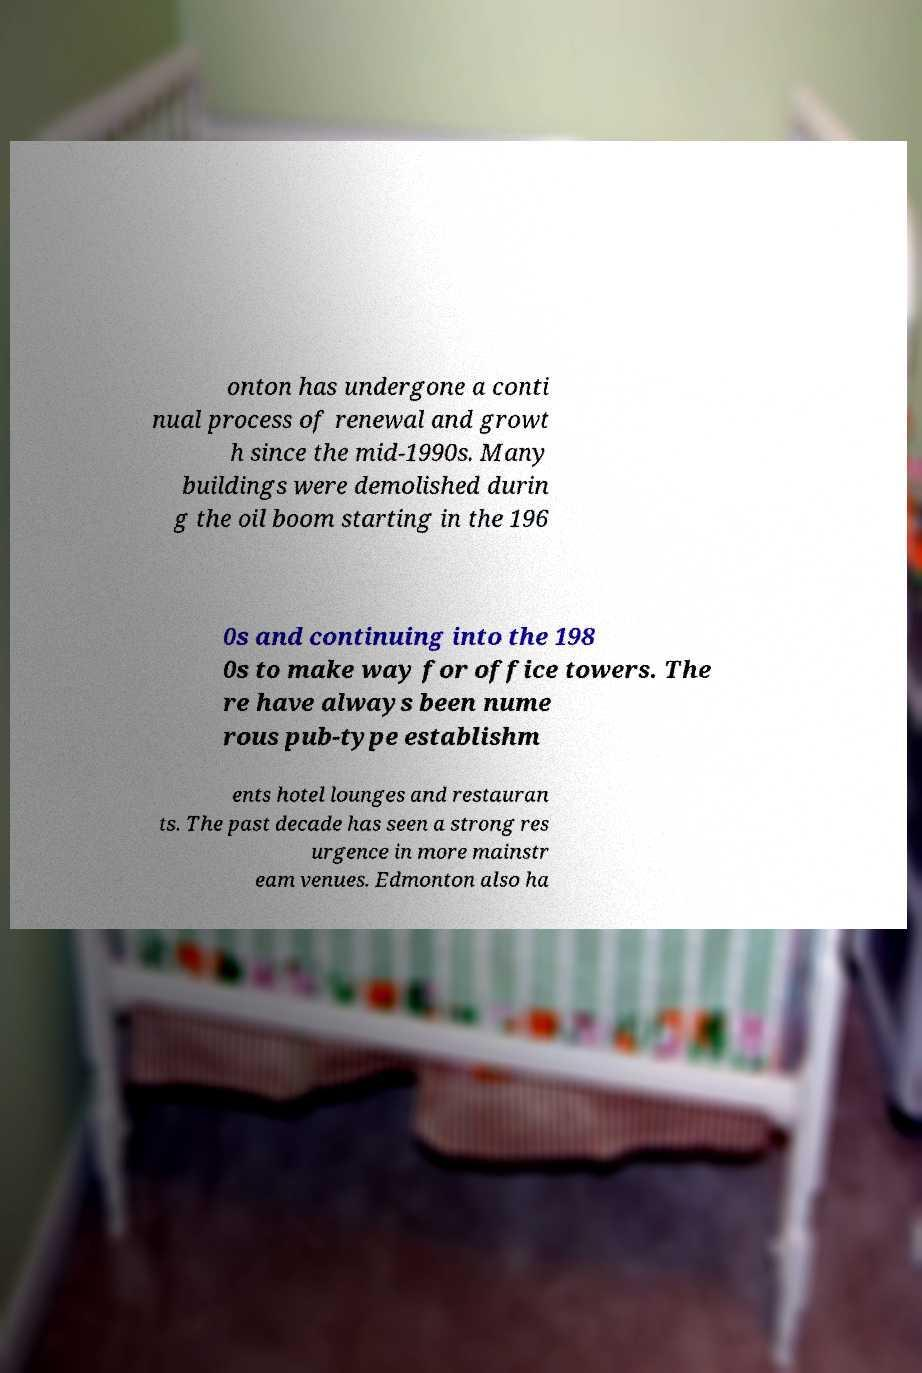Could you assist in decoding the text presented in this image and type it out clearly? onton has undergone a conti nual process of renewal and growt h since the mid-1990s. Many buildings were demolished durin g the oil boom starting in the 196 0s and continuing into the 198 0s to make way for office towers. The re have always been nume rous pub-type establishm ents hotel lounges and restauran ts. The past decade has seen a strong res urgence in more mainstr eam venues. Edmonton also ha 